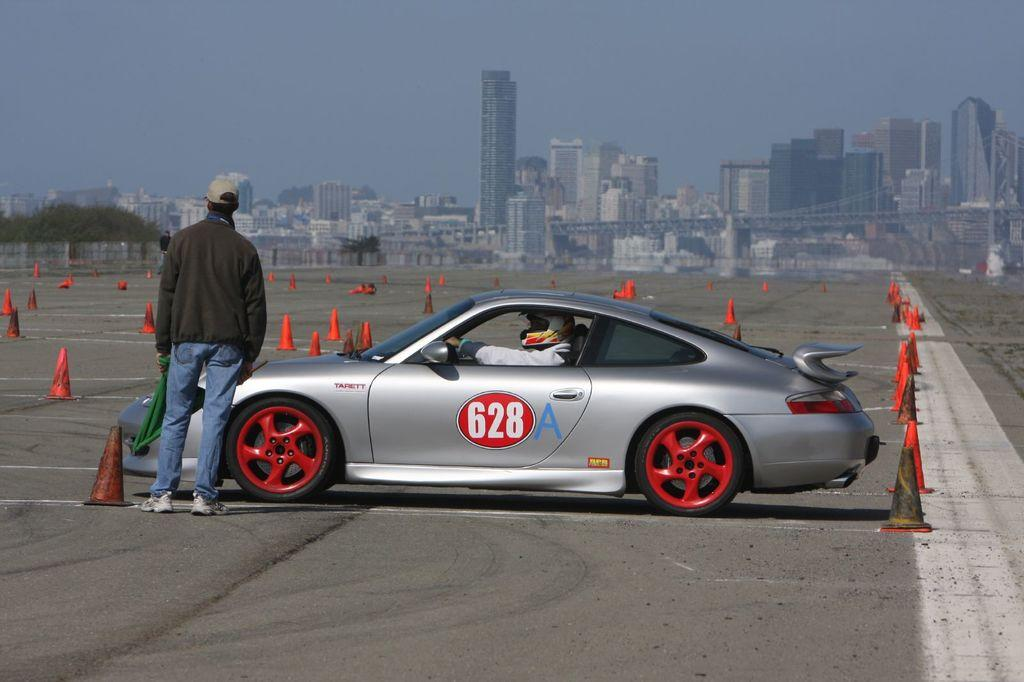What is the main subject in the middle of the image? There is a car in the middle of the image. Can you describe the person inside the car? A person is visible inside the car. What structure can be seen at the top of the image? There is a building at the top of the image. What is visible in the sky at the top of the image? The sky is visible at the top of the image. What type of business is being conducted in the car? There is no indication of any business being conducted in the car, as the image only shows a person inside a car and a building in the background. 